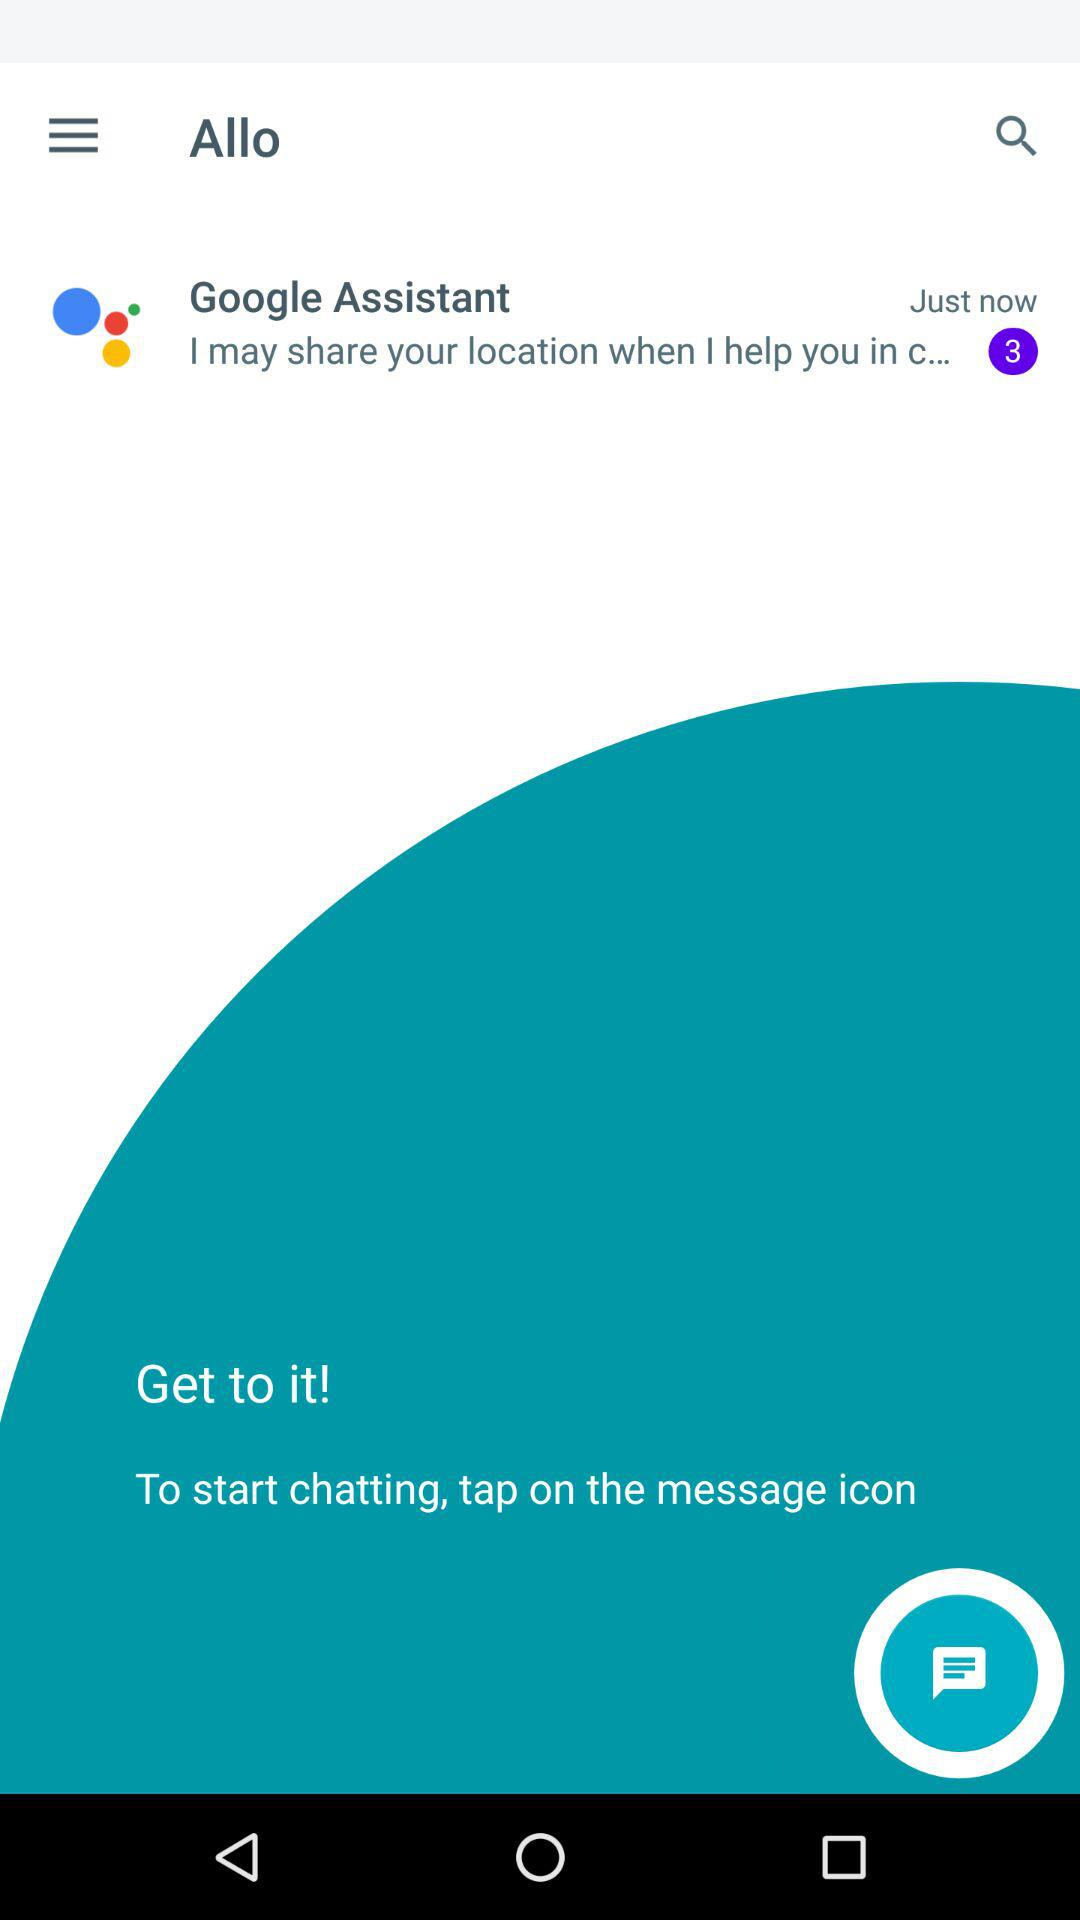What is the instruction to start the chat? To start the chat, "tap on the message icon". 